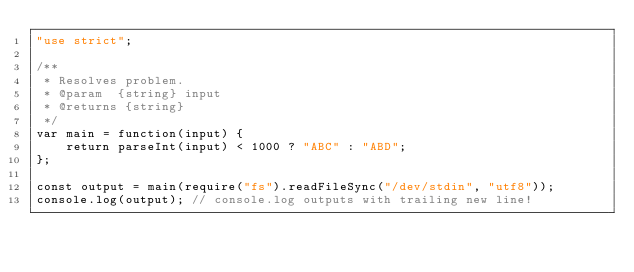<code> <loc_0><loc_0><loc_500><loc_500><_JavaScript_>"use strict";

/**
 * Resolves problem.
 * @param  {string} input
 * @returns {string}
 */
var main = function(input) {
    return parseInt(input) < 1000 ? "ABC" : "ABD";
};

const output = main(require("fs").readFileSync("/dev/stdin", "utf8"));
console.log(output); // console.log outputs with trailing new line!
</code> 